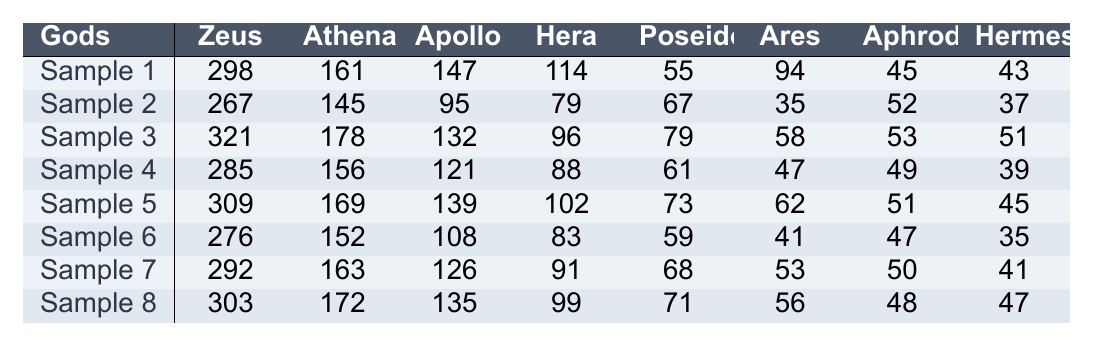How many times is Zeus referenced in Sample 1? In Sample 1, the reference count for Zeus is directly listed under the column for Zeus. The value is 298.
Answer: 298 What is the total number of references for Athena across all samples? To find the total number of references for Athena, sum the values from all samples: 161 + 145 + 178 + 156 + 169 + 152 + 163 + 172 = 1296.
Answer: 1296 Which god has the highest number of references in Sample 3? In Sample 3, the counts are compared: Zeus (321), Athena (178), Apollo (132), Hera (96), Poseidon (79), Ares (58), Aphrodite (53), Hermes (51). Zeus has the highest, with 321 references.
Answer: Zeus What is the average number of references for Apollo across all samples? To calculate the average for Apollo, sum the values for Apollo (147 + 95 + 132 + 121 + 139 + 108 + 126 + 135 = 963) and divide by the number of samples (8). So, the average is 963 / 8 = 120.375.
Answer: 120.375 Is there a sample where Ares is referenced more than 50 times? Checking each sample for Ares reveals the counts: 94, 35, 58, 47, 62, 41, 53, 56. The values for Sample 1 (94) and Sample 5 (62) show that in those samples, Ares was referenced more than 50 times.
Answer: Yes What is the difference in references to Poseidon between Sample 5 and Sample 7? The value for Poseidon in Sample 5 is 73 and in Sample 7 is 68. The difference is calculated as 73 - 68 = 5.
Answer: 5 Which god has the least number of references in Sample 4? The counts in Sample 4 are: Zeus (285), Athena (156), Apollo (121), Hera (88), Poseidon (61), Ares (47), Aphrodite (49), Hermes (39). The least count is for Hermes at 39.
Answer: Hermes What is the total number of references for all gods in Sample 2? To find the total for Sample 2, add the counts: 267 + 145 + 95 + 79 + 67 + 35 + 52 + 37 = 807.
Answer: 807 How does the reference count of Athena in Sample 8 compare to that in Sample 6? In Sample 8, Athena has 172 references, while in Sample 6, Athena has 152 references. Comparing, 172 > 152 means Athena is referenced more in Sample 8.
Answer: More What is the median number of references for Hermes across all samples? The values for Hermes are: 43, 37, 51, 39, 45, 35, 41, 47. Arranging these in order: 35, 37, 39, 41, 43, 45, 47, 51. The median (the middle value in an even dataset) would be the average of 41 and 43, which is (41 + 43) / 2 = 42.
Answer: 42 